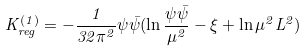Convert formula to latex. <formula><loc_0><loc_0><loc_500><loc_500>K ^ { ( 1 ) } _ { r e g } = - \frac { 1 } { 3 2 \pi ^ { 2 } } \psi \bar { \psi } ( \ln \frac { \psi \bar { \psi } } { \mu ^ { 2 } } - \xi + \ln \mu ^ { 2 } L ^ { 2 } )</formula> 